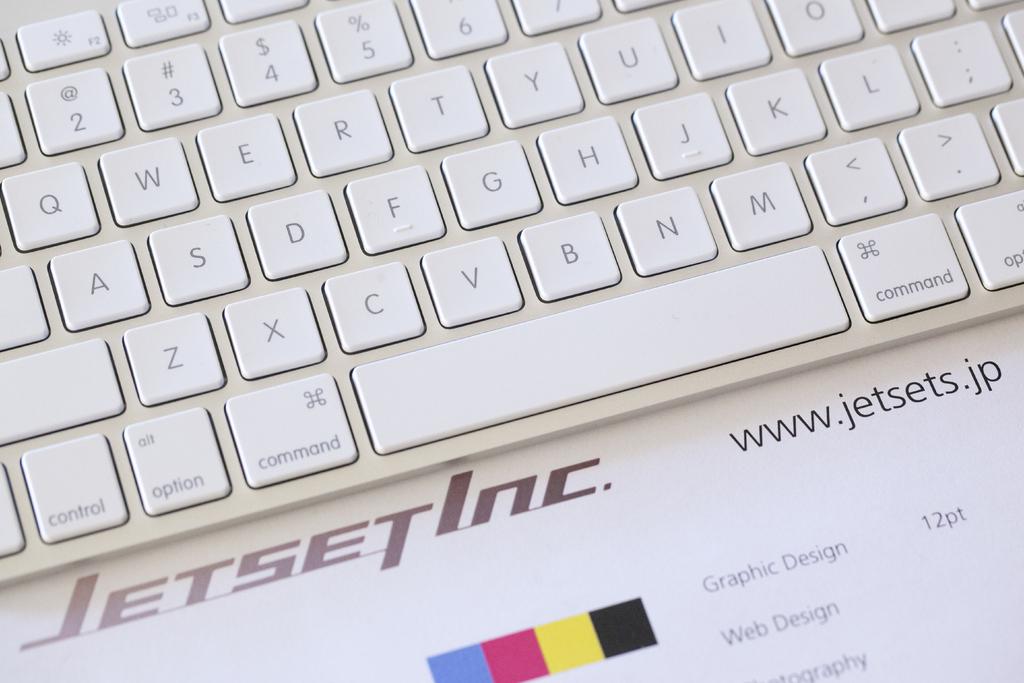What is the website on this photo?
Your response must be concise. Www.jetsets.jp. What brand is the keyboard?
Your answer should be compact. Jetset inc. 